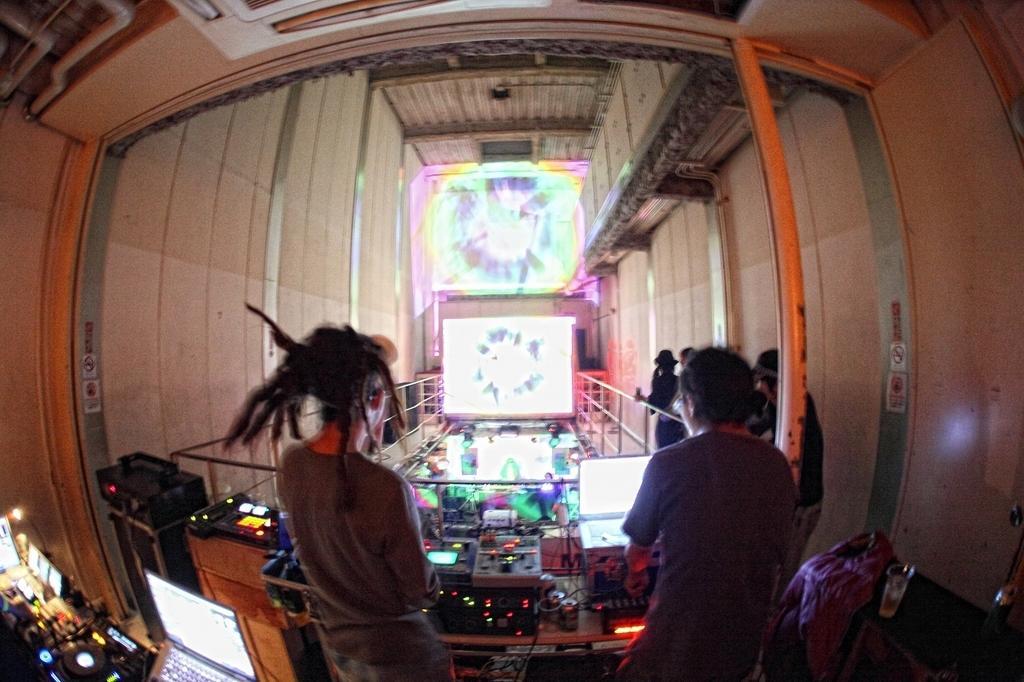Describe this image in one or two sentences. In this image we can see a few people, there are laptops, musical instruments, cables and some other objects, also we can see the grille, wall and the screens. 